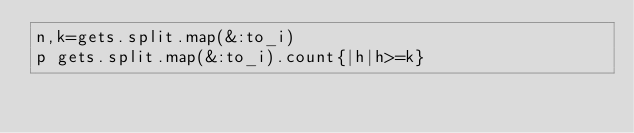<code> <loc_0><loc_0><loc_500><loc_500><_Ruby_>n,k=gets.split.map(&:to_i)
p gets.split.map(&:to_i).count{|h|h>=k}
</code> 